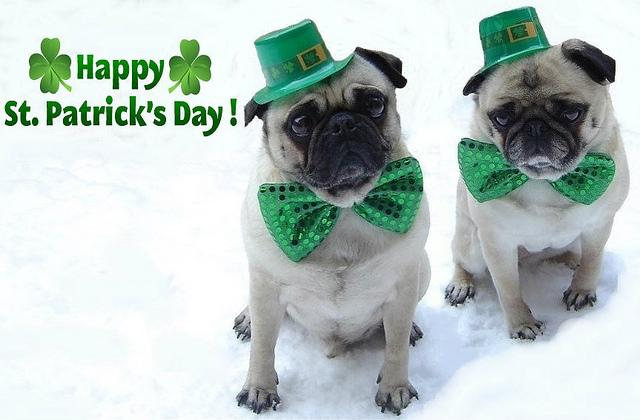What nationality is associated with the holiday being celebrated here? Please explain your reasoning. irish. The green is the color of st. paddy's day who was a real person that lived in this country.  the four leaf clover is also indicative of this holiday. 